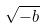Convert formula to latex. <formula><loc_0><loc_0><loc_500><loc_500>\sqrt { - b }</formula> 